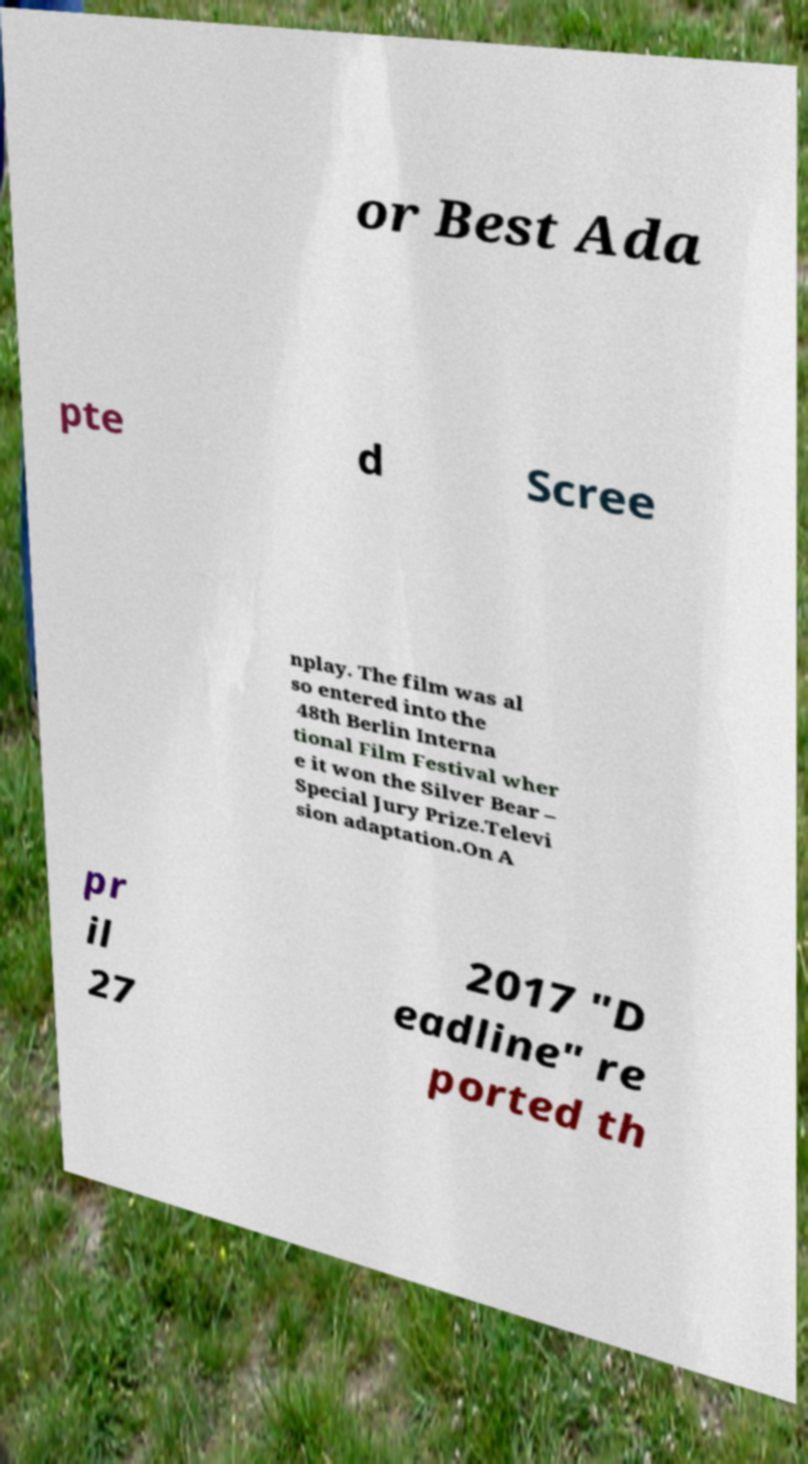For documentation purposes, I need the text within this image transcribed. Could you provide that? or Best Ada pte d Scree nplay. The film was al so entered into the 48th Berlin Interna tional Film Festival wher e it won the Silver Bear – Special Jury Prize.Televi sion adaptation.On A pr il 27 2017 "D eadline" re ported th 